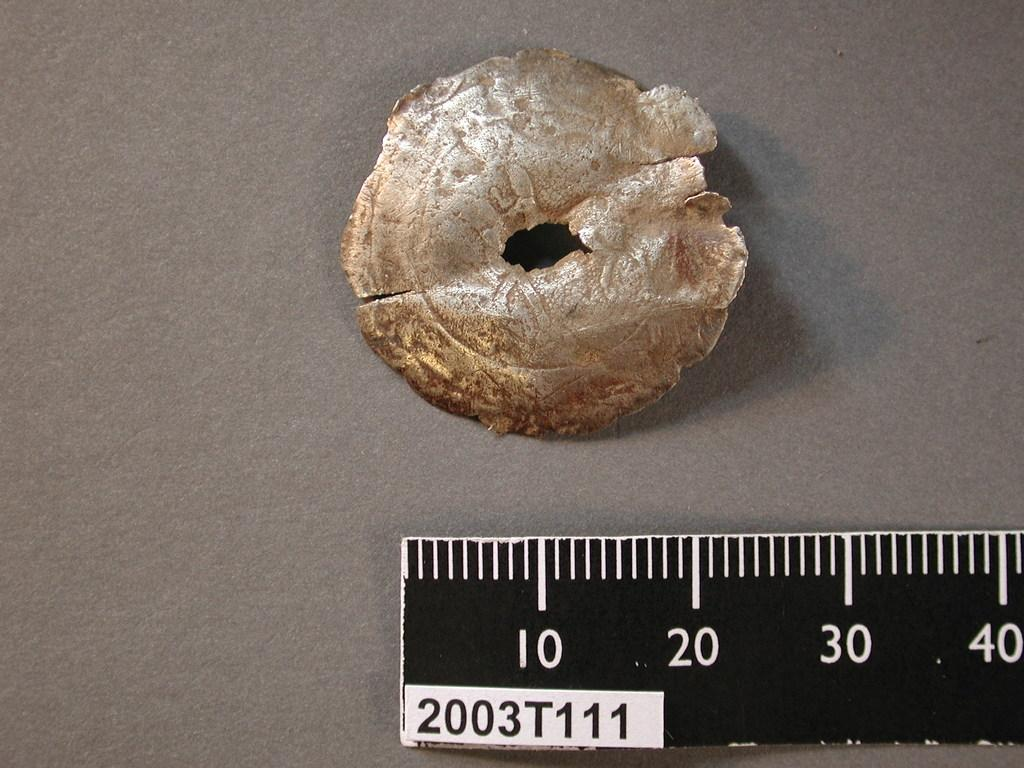What material is the object in the image made of? There is a piece of metal in the image. What device is present in the image? There is a scale in the image. On what surface is the scale placed? The scale is placed on a surface. What type of voice can be heard coming from the metal piece in the image? There is no voice present in the image; it is a piece of metal and a scale. How many babies are visible in the image? There are no babies present in the image. 